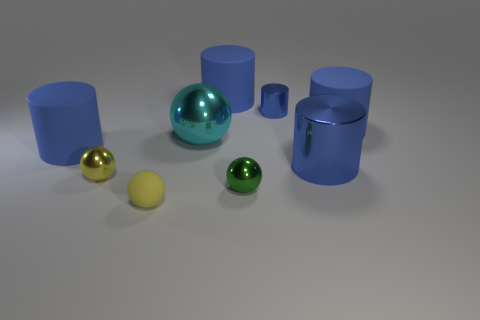Are there any balls that are left of the large blue rubber thing that is behind the small blue thing?
Ensure brevity in your answer.  Yes. What number of things are blue cylinders or large cyan cubes?
Keep it short and to the point. 5. What shape is the blue thing that is behind the cyan metal ball and on the right side of the tiny blue object?
Your answer should be compact. Cylinder. Does the large cylinder on the left side of the big cyan object have the same material as the big sphere?
Your answer should be compact. No. What number of objects are either large red cylinders or large rubber things that are to the right of the large cyan sphere?
Keep it short and to the point. 2. The other large object that is made of the same material as the big cyan object is what color?
Provide a short and direct response. Blue. What number of large gray spheres are the same material as the cyan sphere?
Make the answer very short. 0. How many tiny yellow shiny things are there?
Your response must be concise. 1. There is a shiny object that is behind the big cyan metal thing; does it have the same color as the matte cylinder in front of the cyan sphere?
Provide a succinct answer. Yes. There is a big metallic ball; what number of large blue rubber things are left of it?
Ensure brevity in your answer.  1. 